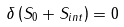Convert formula to latex. <formula><loc_0><loc_0><loc_500><loc_500>\delta \left ( { S } _ { 0 } + { S } _ { i n t } \right ) = 0</formula> 